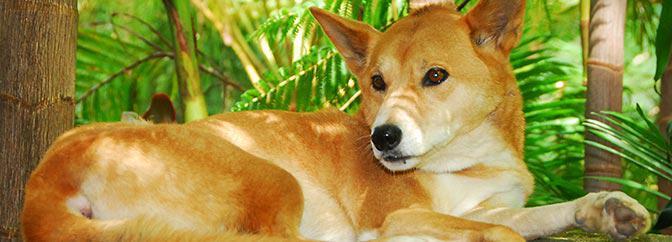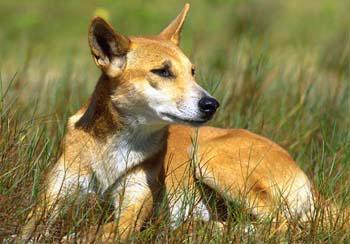The first image is the image on the left, the second image is the image on the right. Analyze the images presented: Is the assertion "There are only two dogs and both are looking in different directions." valid? Answer yes or no. Yes. The first image is the image on the left, the second image is the image on the right. Examine the images to the left and right. Is the description "Each photo shows a single dingo in the wild." accurate? Answer yes or no. Yes. 